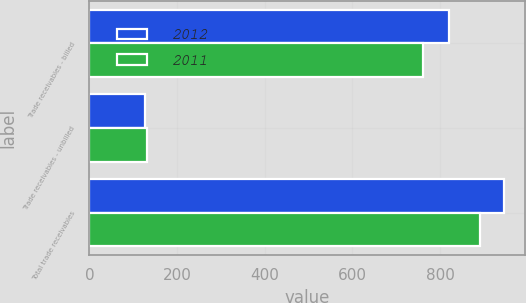Convert chart. <chart><loc_0><loc_0><loc_500><loc_500><stacked_bar_chart><ecel><fcel>Trade receivables - billed<fcel>Trade receivables - unbilled<fcel>Total trade receivables<nl><fcel>2012<fcel>819.5<fcel>126.1<fcel>945.6<nl><fcel>2011<fcel>760.8<fcel>130.8<fcel>891.6<nl></chart> 